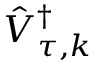Convert formula to latex. <formula><loc_0><loc_0><loc_500><loc_500>\hat { V } _ { \tau , k } ^ { \dag }</formula> 